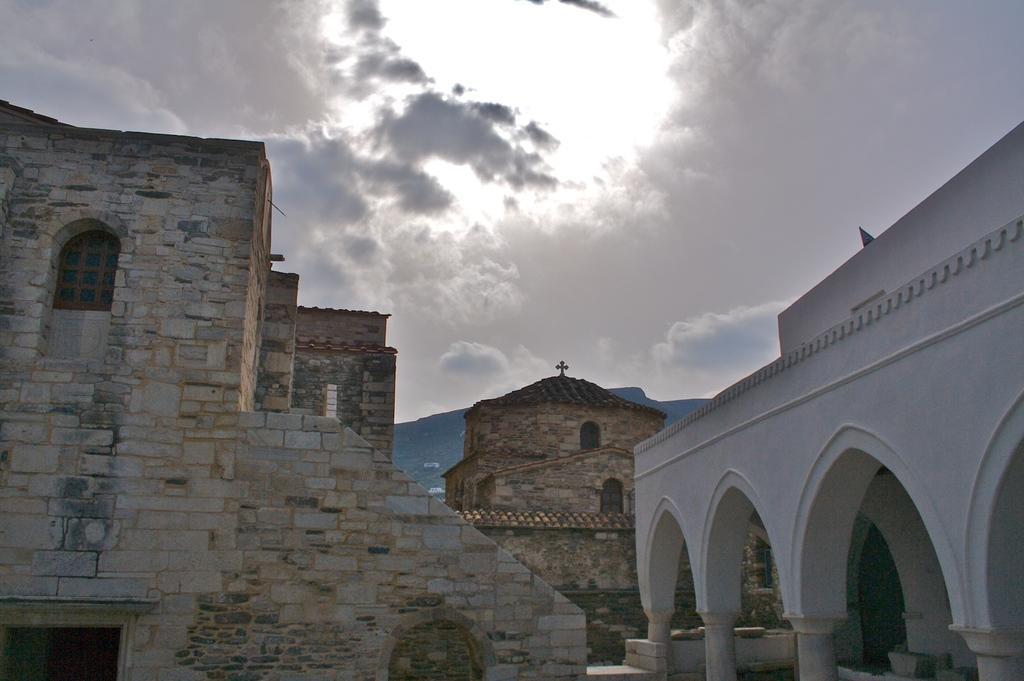Can you describe this image briefly? In this image I can see few buildings in white, cream and gray color. Background the sky is in white and gray color. 